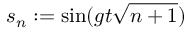<formula> <loc_0><loc_0><loc_500><loc_500>s _ { n } \colon = \sin ( g t \sqrt { n + 1 } )</formula> 